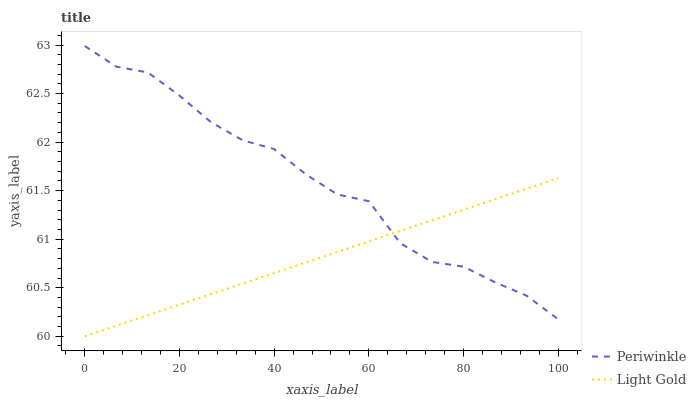Does Light Gold have the minimum area under the curve?
Answer yes or no. Yes. Does Periwinkle have the maximum area under the curve?
Answer yes or no. Yes. Does Periwinkle have the minimum area under the curve?
Answer yes or no. No. Is Light Gold the smoothest?
Answer yes or no. Yes. Is Periwinkle the roughest?
Answer yes or no. Yes. Is Periwinkle the smoothest?
Answer yes or no. No. Does Light Gold have the lowest value?
Answer yes or no. Yes. Does Periwinkle have the lowest value?
Answer yes or no. No. Does Periwinkle have the highest value?
Answer yes or no. Yes. Does Periwinkle intersect Light Gold?
Answer yes or no. Yes. Is Periwinkle less than Light Gold?
Answer yes or no. No. Is Periwinkle greater than Light Gold?
Answer yes or no. No. 